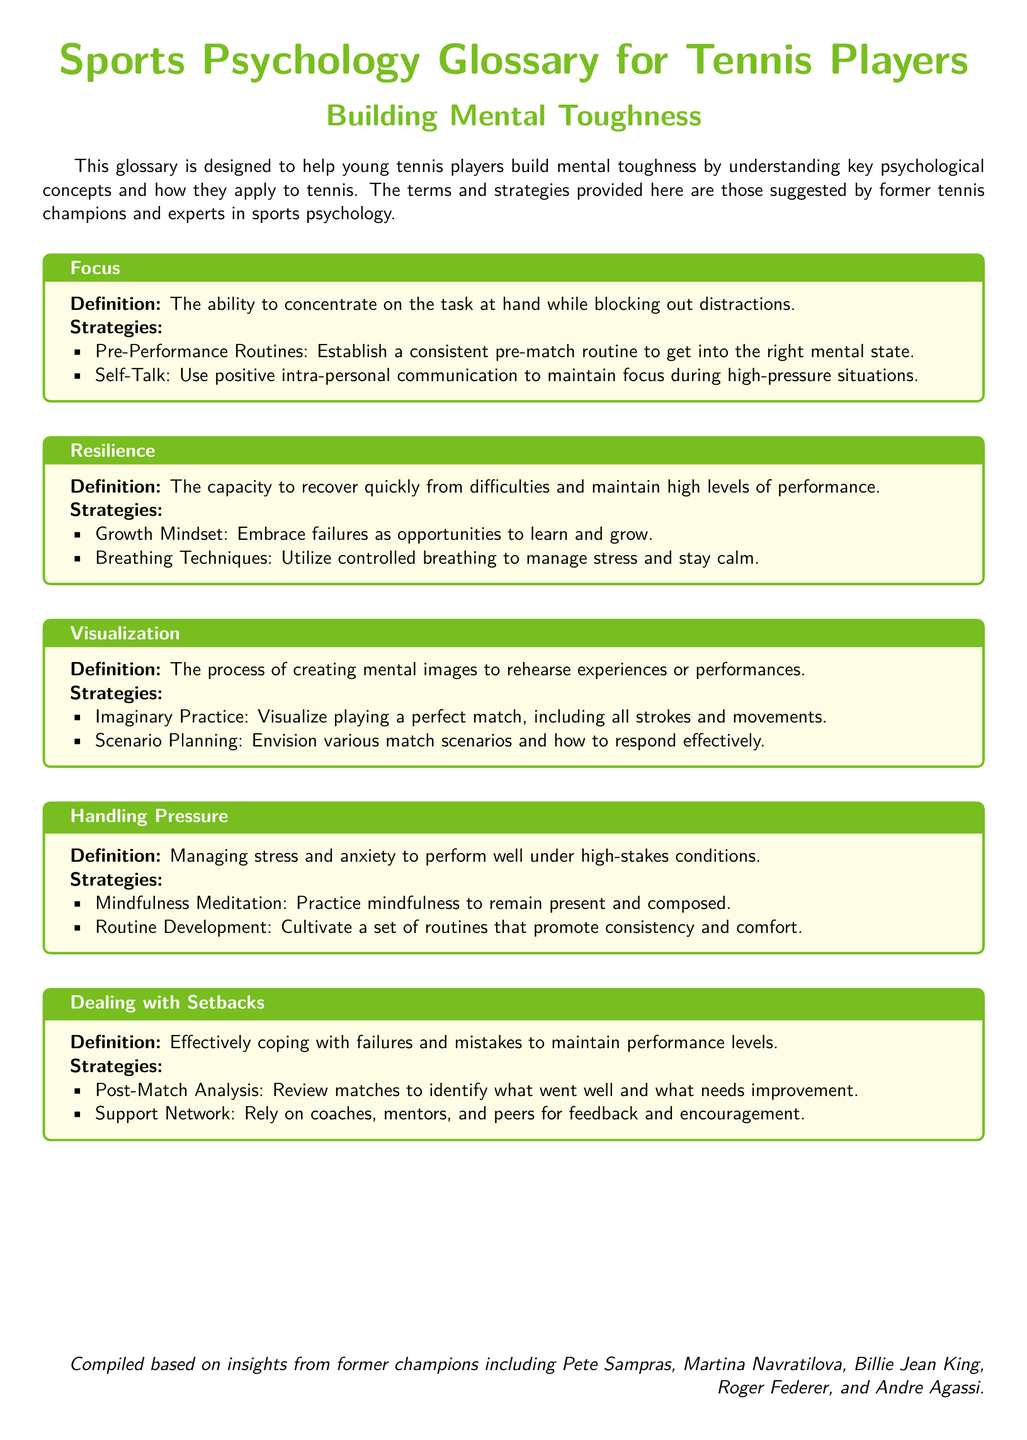What is the title of the document? The title of the document is presented prominently at the beginning, indicating its focus on sports psychology for tennis players.
Answer: Sports Psychology Glossary for Tennis Players Who are some former champions mentioned in the document? The document lists several retired champions who contributed insights to the glossary.
Answer: Pete Sampras, Martina Navratilova, Billie Jean King, Roger Federer, Andre Agassi What term describes the ability to concentrate and block out distractions? The glossary defines a specific term that represents focusing on the task while ignoring distractions.
Answer: Focus What strategy is suggested for handling pressure? The document outlines specific strategies to manage stress during high-stakes situations, one of which is related to a practice method.
Answer: Mindfulness Meditation What type of mindset is encouraged for resilience? The glossary emphasizes a certain mindset as important for coping with setbacks and improving performance.
Answer: Growth Mindset How many strategies are provided for each term? Each term in the glossary includes details on strategies, highlighting the structured approach of the document.
Answer: Two 